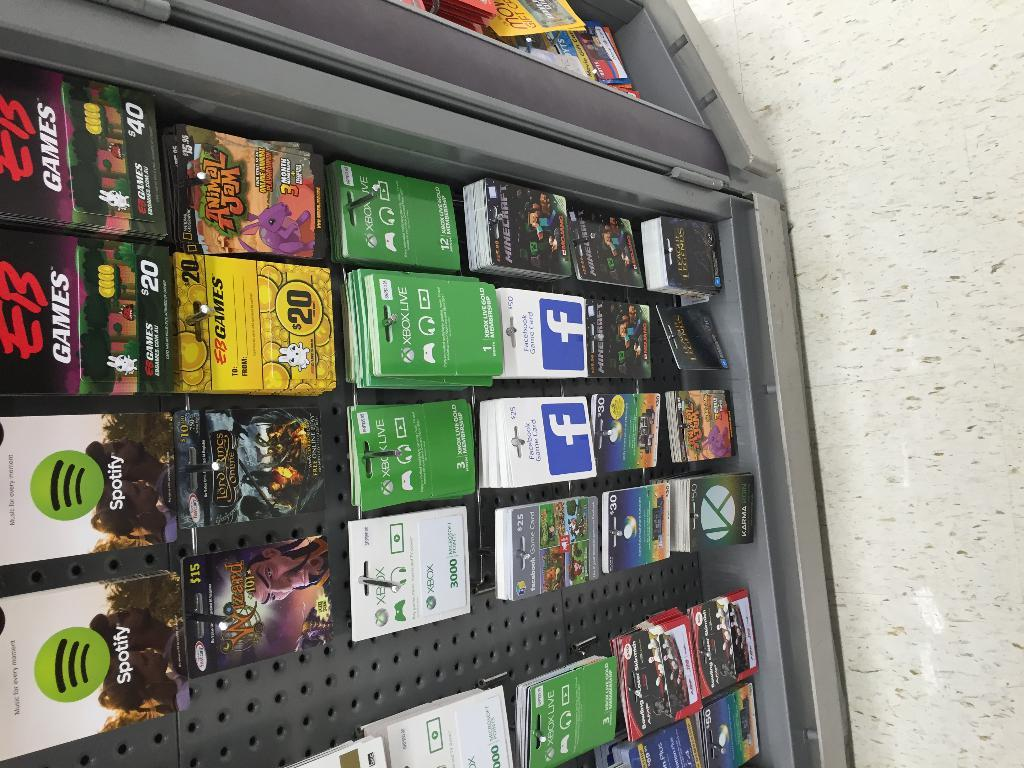Provide a one-sentence caption for the provided image. A rack of gift cards for various companies such as Spotify and Facebook. 